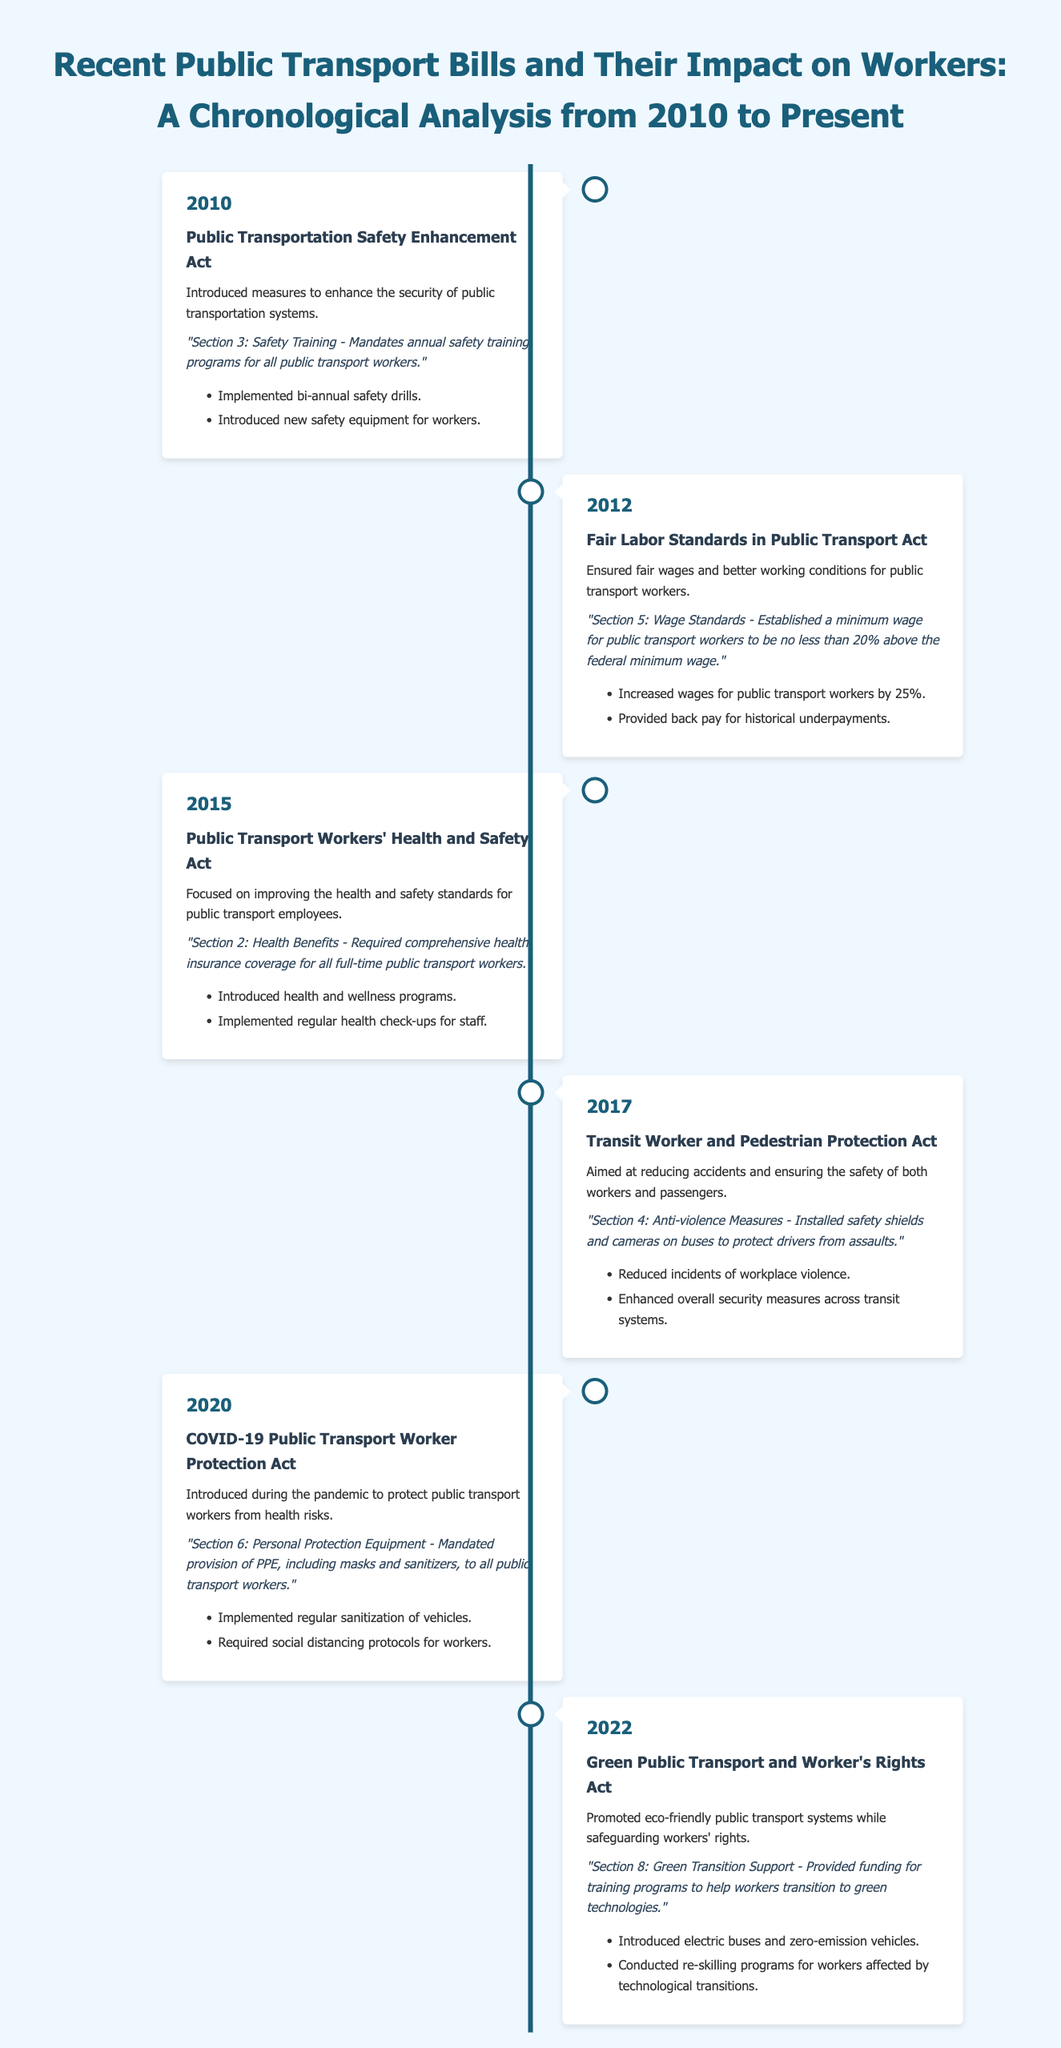What was the bill introduced in 2010? The 2010 bill was the Public Transportation Safety Enhancement Act.
Answer: Public Transportation Safety Enhancement Act What key passage is highlighted in the 2012 bill? The key passage in the 2012 bill states that public transport workers' minimum wage should be no less than 20% above the federal minimum wage.
Answer: "Section 5: Wage Standards - Established a minimum wage for public transport workers to be no less than 20% above the federal minimum wage." How much were wages increased for workers in 2012? Wages for public transport workers were increased by 25%.
Answer: 25% What was the focus of the 2015 bill? The focus of the 2015 bill was on improving health and safety standards for public transport employees.
Answer: Improving health and safety standards Which act mandated PPE provision during the pandemic? The COVID-19 Public Transport Worker Protection Act mandated PPE provision during the pandemic.
Answer: COVID-19 Public Transport Worker Protection Act What reform was introduced in the 2020 bill? The 2020 bill introduced regular sanitization of vehicles as a reform.
Answer: Regular sanitization of vehicles What year was the Green Public Transport and Worker's Rights Act introduced? The Green Public Transport and Worker's Rights Act was introduced in 2022.
Answer: 2022 How many safety drills were implemented by the 2010 bill? The 2010 bill implemented bi-annual safety drills.
Answer: Bi-annual safety drills 